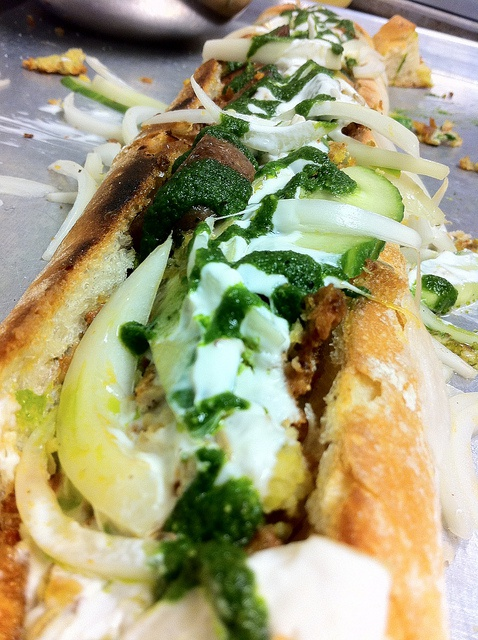Describe the objects in this image and their specific colors. I can see a sandwich in black, ivory, khaki, and tan tones in this image. 